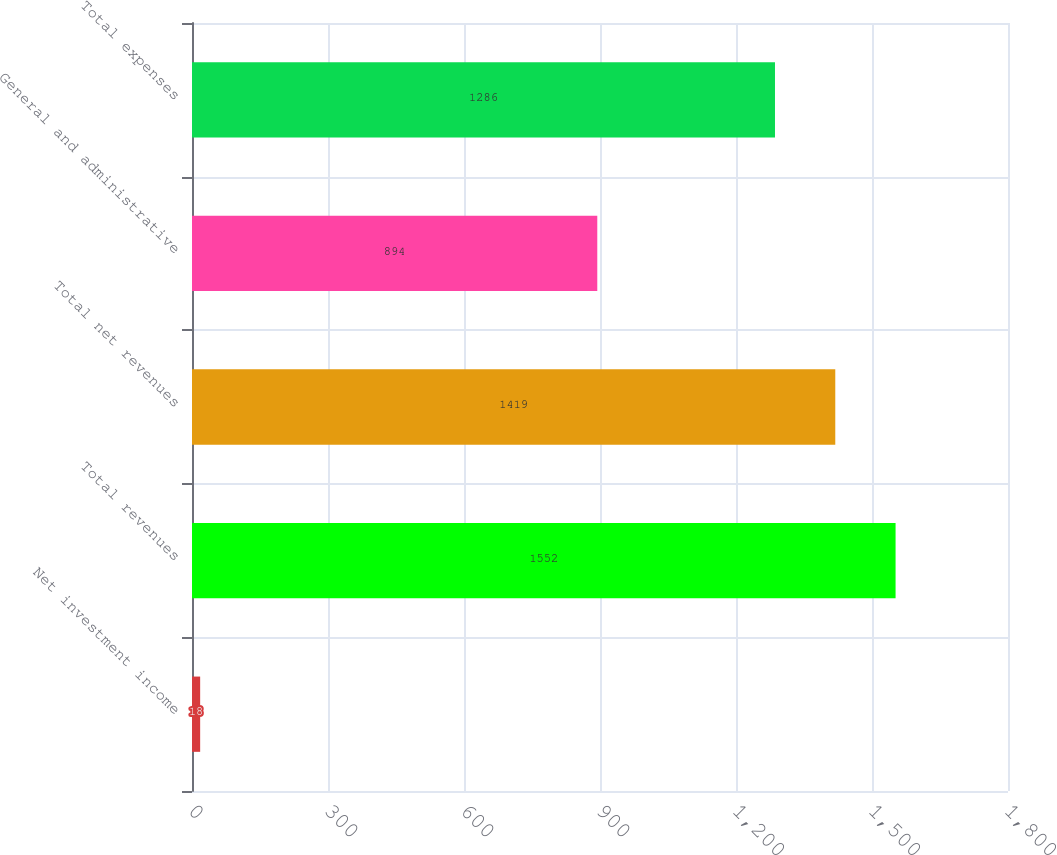Convert chart. <chart><loc_0><loc_0><loc_500><loc_500><bar_chart><fcel>Net investment income<fcel>Total revenues<fcel>Total net revenues<fcel>General and administrative<fcel>Total expenses<nl><fcel>18<fcel>1552<fcel>1419<fcel>894<fcel>1286<nl></chart> 